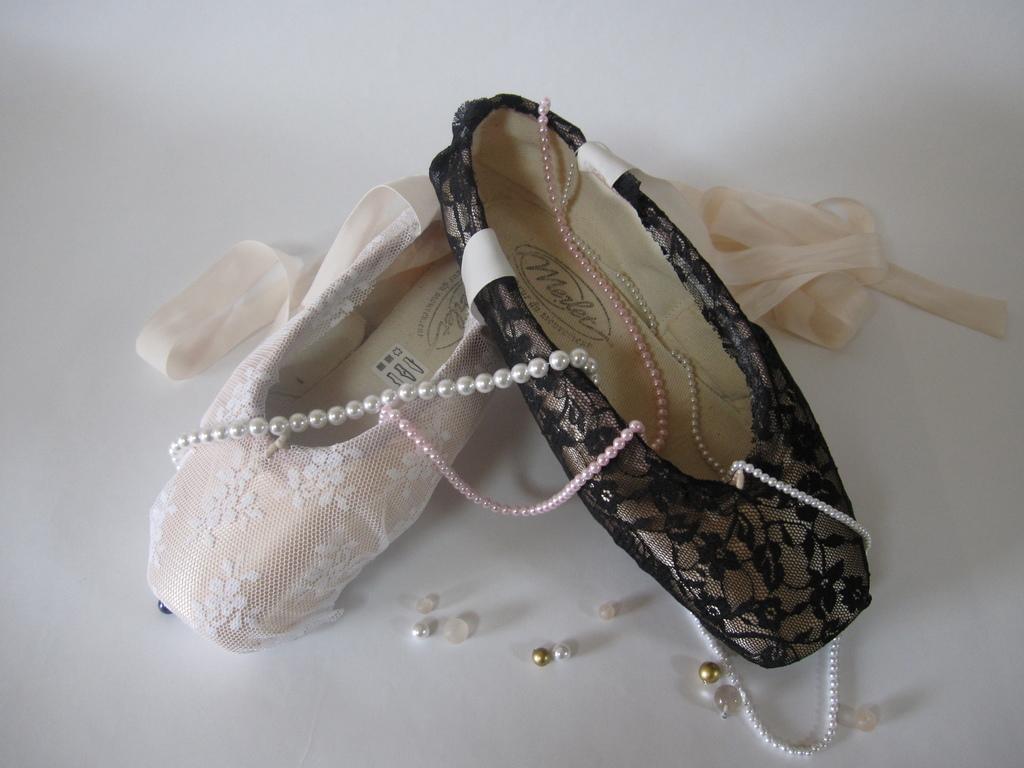Describe this image in one or two sentences. In the picture there are two different shoes of a woman and on the shoes there are pearl chains and ribbons beside the shoes. 